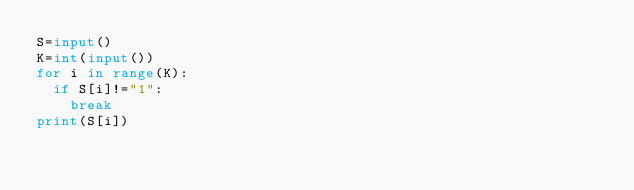Convert code to text. <code><loc_0><loc_0><loc_500><loc_500><_Python_>S=input()
K=int(input())
for i in range(K):
  if S[i]!="1":
    break
print(S[i])</code> 